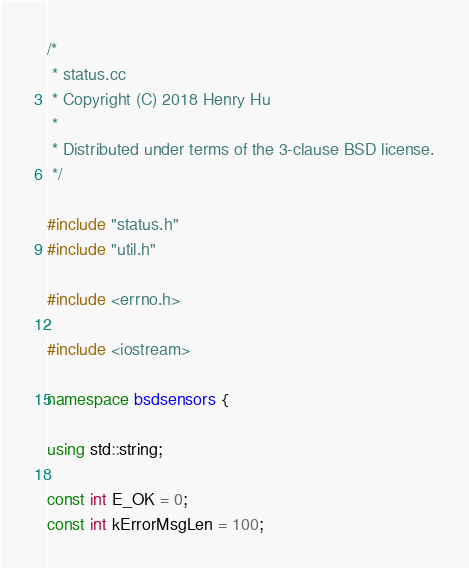Convert code to text. <code><loc_0><loc_0><loc_500><loc_500><_C++_>/*
 * status.cc
 * Copyright (C) 2018 Henry Hu
 *
 * Distributed under terms of the 3-clause BSD license.
 */

#include "status.h"
#include "util.h"

#include <errno.h>

#include <iostream>

namespace bsdsensors {

using std::string;

const int E_OK = 0;
const int kErrorMsgLen = 100;
</code> 